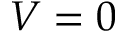<formula> <loc_0><loc_0><loc_500><loc_500>V = 0</formula> 